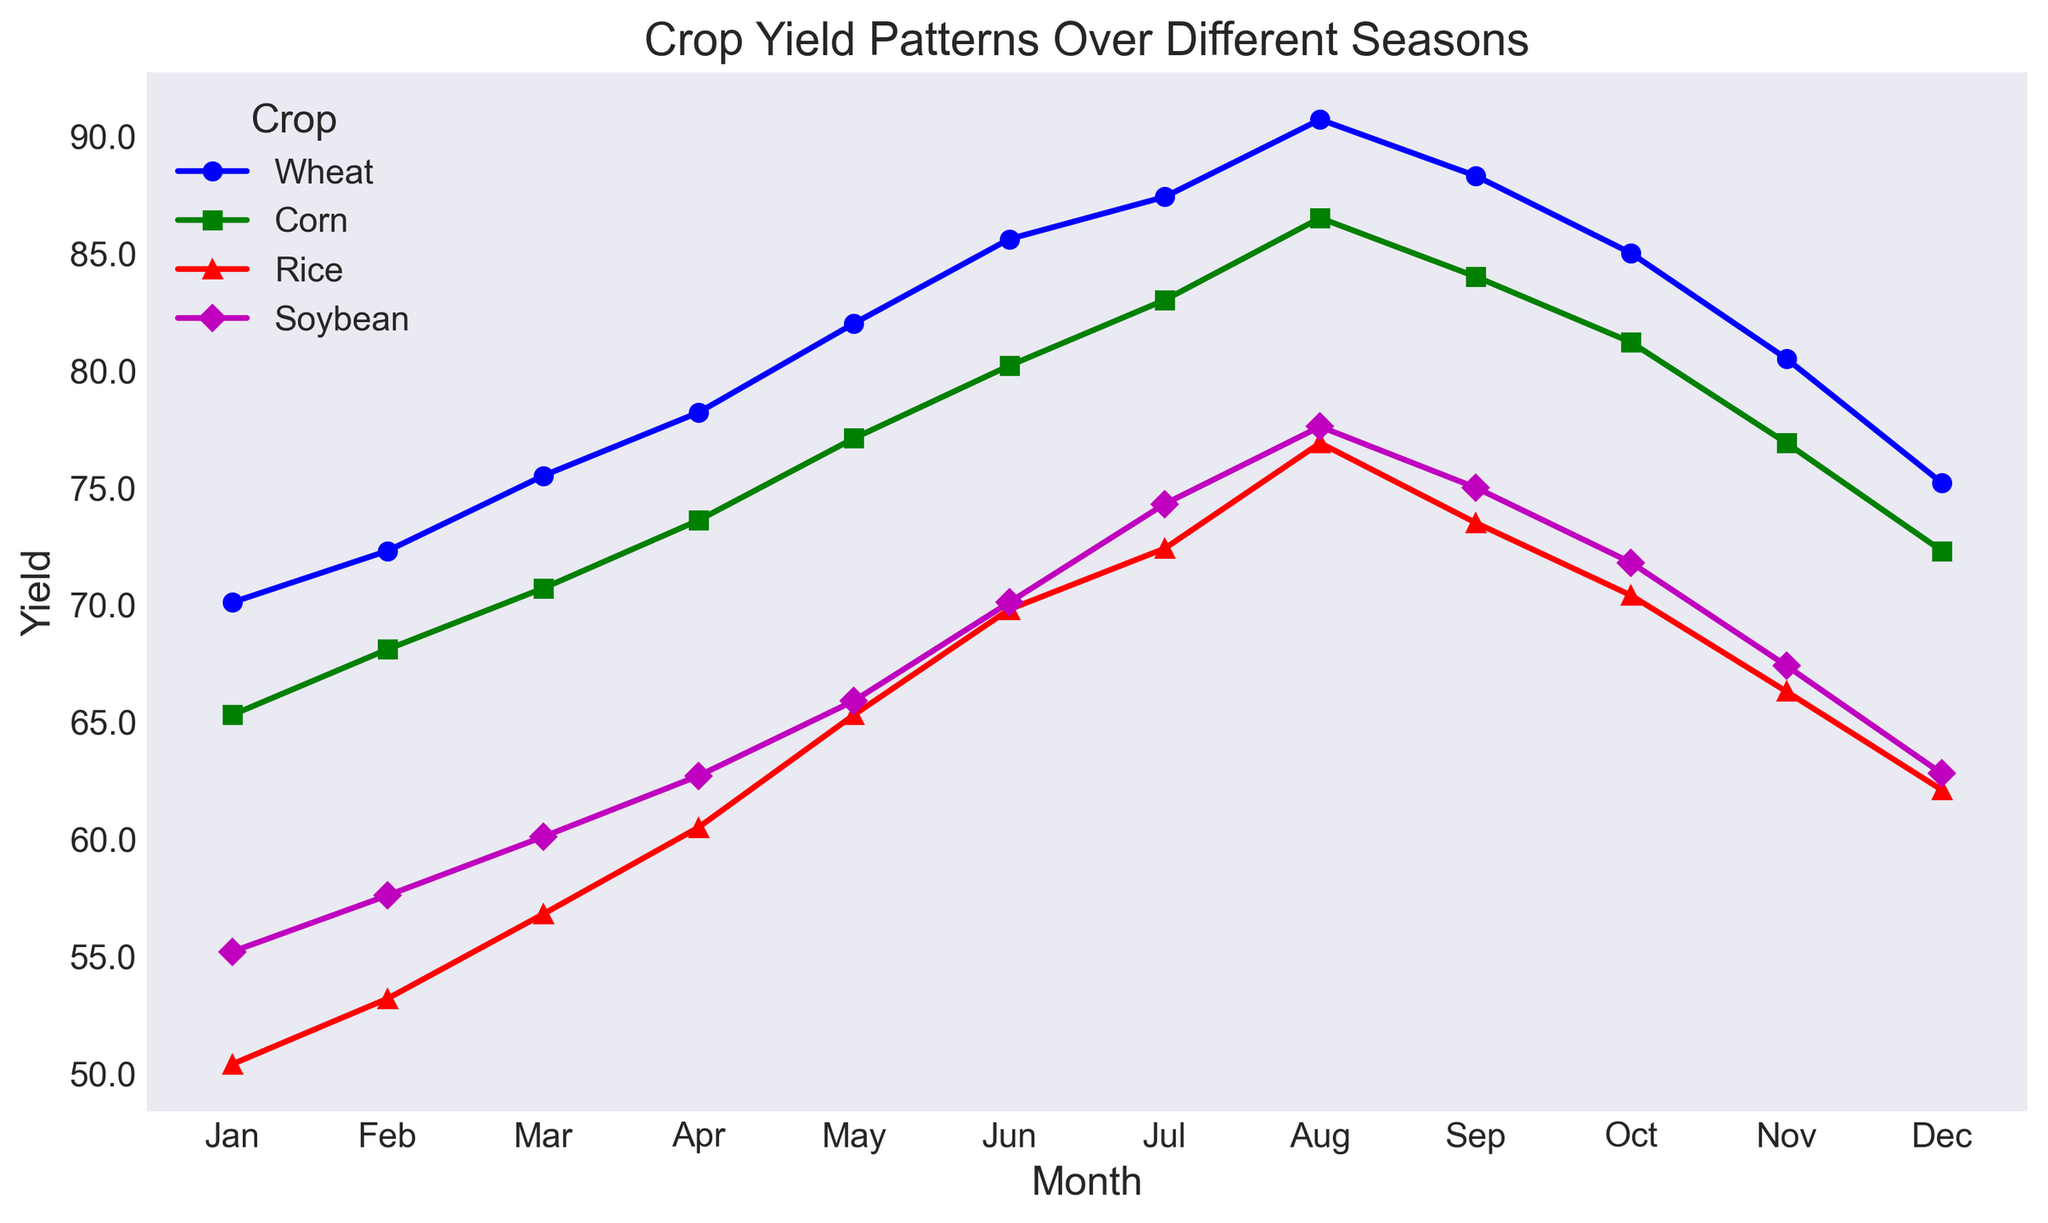Which crop has the highest yield in August? To find this, look at the crop lines or markers for August on the x-axis. Identify which yield value (height on the y-axis) is the highest.
Answer: Wheat How does the yield of Corn in May compare to the yield of Soybean in May? Compare the height of the Corn marker in May (77.1) with the height of the Soybean marker in May (65.9). Determine which one is higher.
Answer: Corn has a higher yield What is the total yield of Wheat and Corn in January? Find the yield values for Wheat (70.1) and Corn (65.3) in January and sum them up. 70.1 + 65.3 = 135.4
Answer: 135.4 Which month shows the maximum yield for Rice? Locate the highest marker for Rice across all months and identify its corresponding month (x-axis).
Answer: August Between which two consecutive months is the yield change for Soybean the greatest? Observe the differences in Soybean's yield markers between each pair of consecutive months. Identify the pair with the largest difference.
Answer: July to August What is the average yield of Rice over the entire year? Add up all the monthly yield values for Rice and divide by the number of months (12). The yields are: 50.4, 53.2, 56.8, 60.5, 65.3, 69.8, 72.4, 76.9, 73.5, 70.4, 66.3, 62.1. Sum = 777.6. Average = 777.6 / 12 = 64.8
Answer: 64.8 In which season does Wheat yield start to decline? Identify the points where Wheat's yield stops increasing and starts decreasing. Notice the month ranges and seasons associated.
Answer: Autumn (September) By how much does the yield of Soybean increase from June to July? Subtract Soybean's yield in June (70.1) from its yield in July (74.3). Difference = 74.3 - 70.1 = 4.2
Answer: 4.2 What color represents the Corn yield trend on the plot? Identify the color used for the Corn yield line by observing the visual attributes.
Answer: Green 